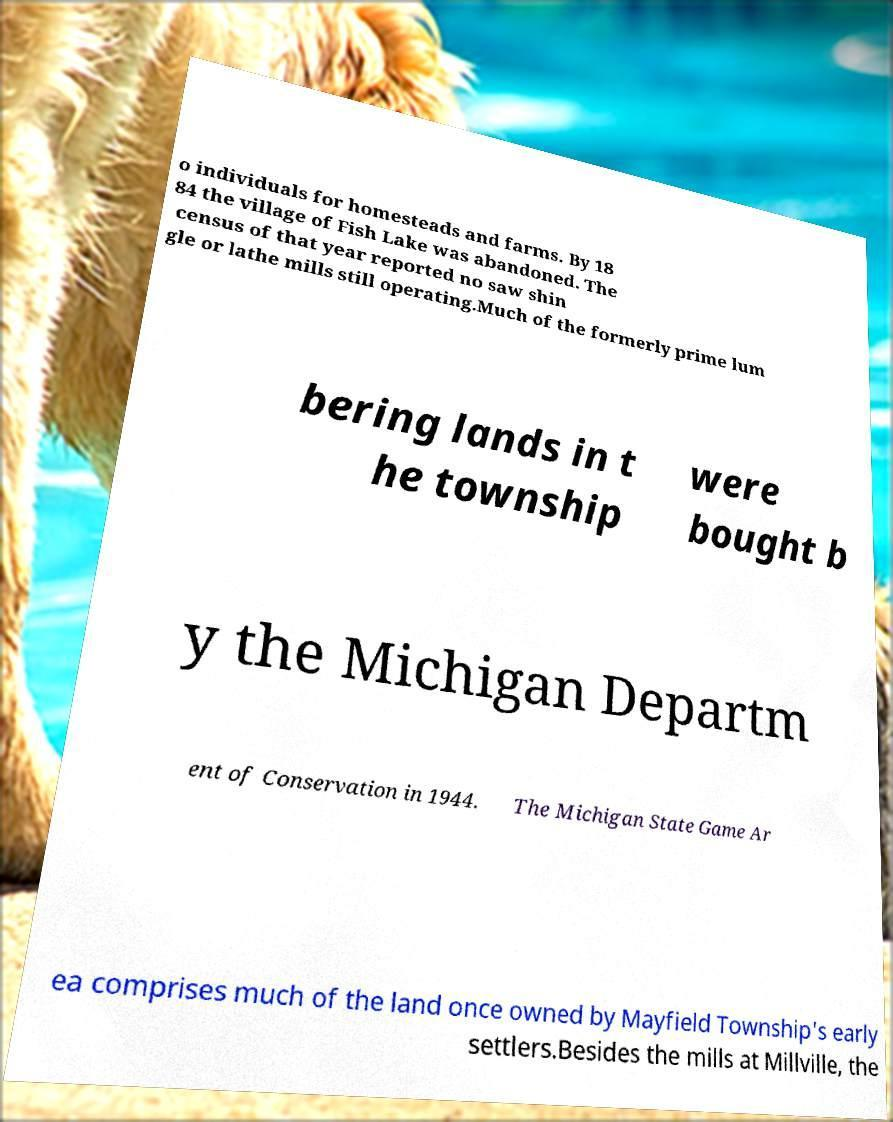Can you read and provide the text displayed in the image?This photo seems to have some interesting text. Can you extract and type it out for me? o individuals for homesteads and farms. By 18 84 the village of Fish Lake was abandoned. The census of that year reported no saw shin gle or lathe mills still operating.Much of the formerly prime lum bering lands in t he township were bought b y the Michigan Departm ent of Conservation in 1944. The Michigan State Game Ar ea comprises much of the land once owned by Mayfield Township's early settlers.Besides the mills at Millville, the 